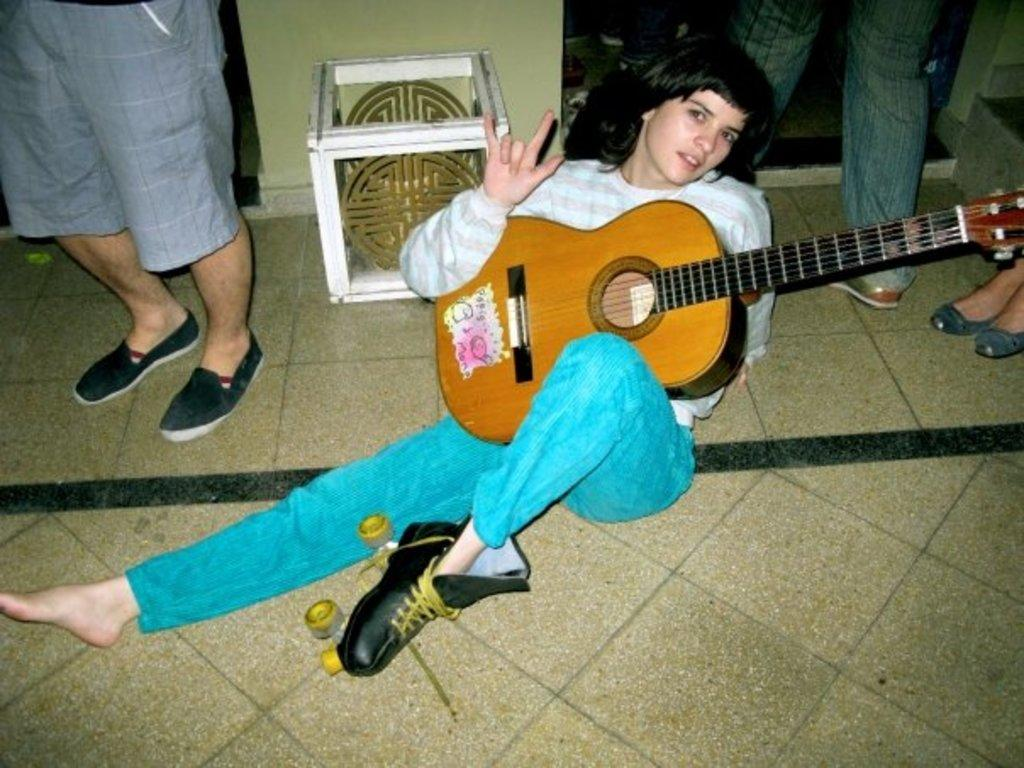Who is the main subject in the image? There is a woman in the image. What is the woman doing in the image? The woman is sitting on the floor and holding a guitar. Are there any other people in the image? Yes, there are three persons near the woman. What type of basketball is the woman playing with in the image? There is no basketball present in the image; the woman is holding a guitar. Can you tell me how many bells are hanging from the guitar in the image? There are no bells hanging from the guitar in the image; it is a standard guitar without any additional attachments. 